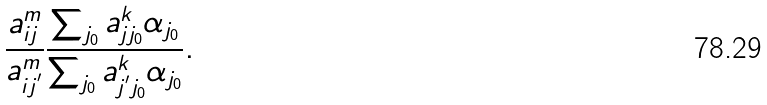<formula> <loc_0><loc_0><loc_500><loc_500>& \frac { a _ { i j } ^ { m } } { a _ { i j ^ { ^ { \prime } } } ^ { m } } \frac { \sum _ { j _ { 0 } } a _ { j j _ { 0 } } ^ { k } \alpha _ { j _ { 0 } } } { \sum _ { j _ { 0 } } a _ { j ^ { ^ { \prime } } j _ { 0 } } ^ { k } \alpha _ { j _ { 0 } } } .</formula> 